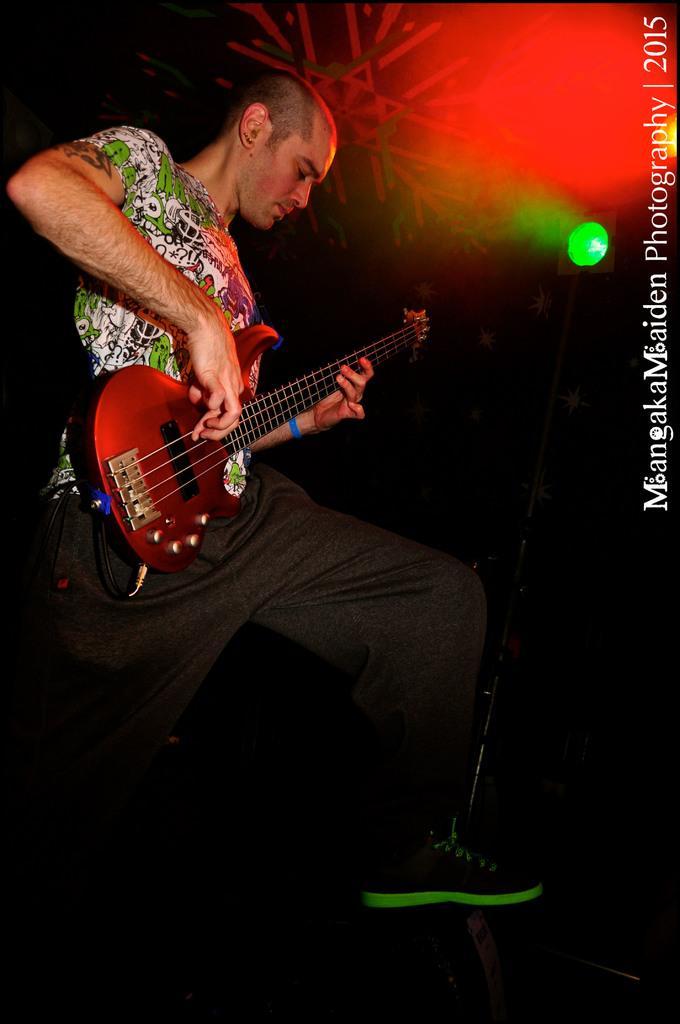Please provide a concise description of this image. In a picture there is only one man standing wearing pants and green white t-shirt and in his hand there is a guitar and he is wearing shoes. 